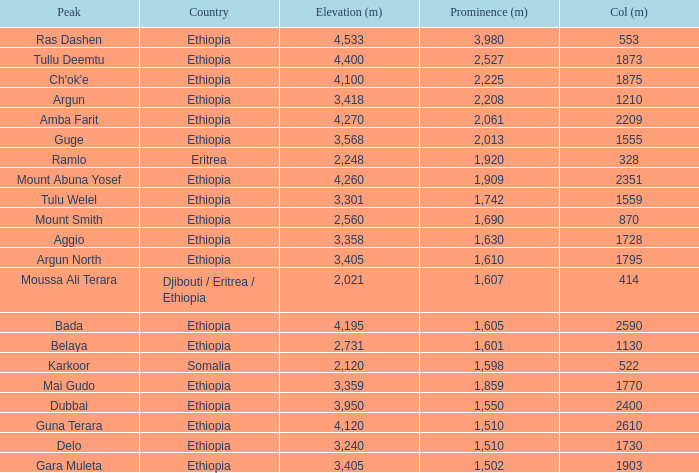What is the sum of the prominence in m of moussa ali terara peak? 1607.0. 